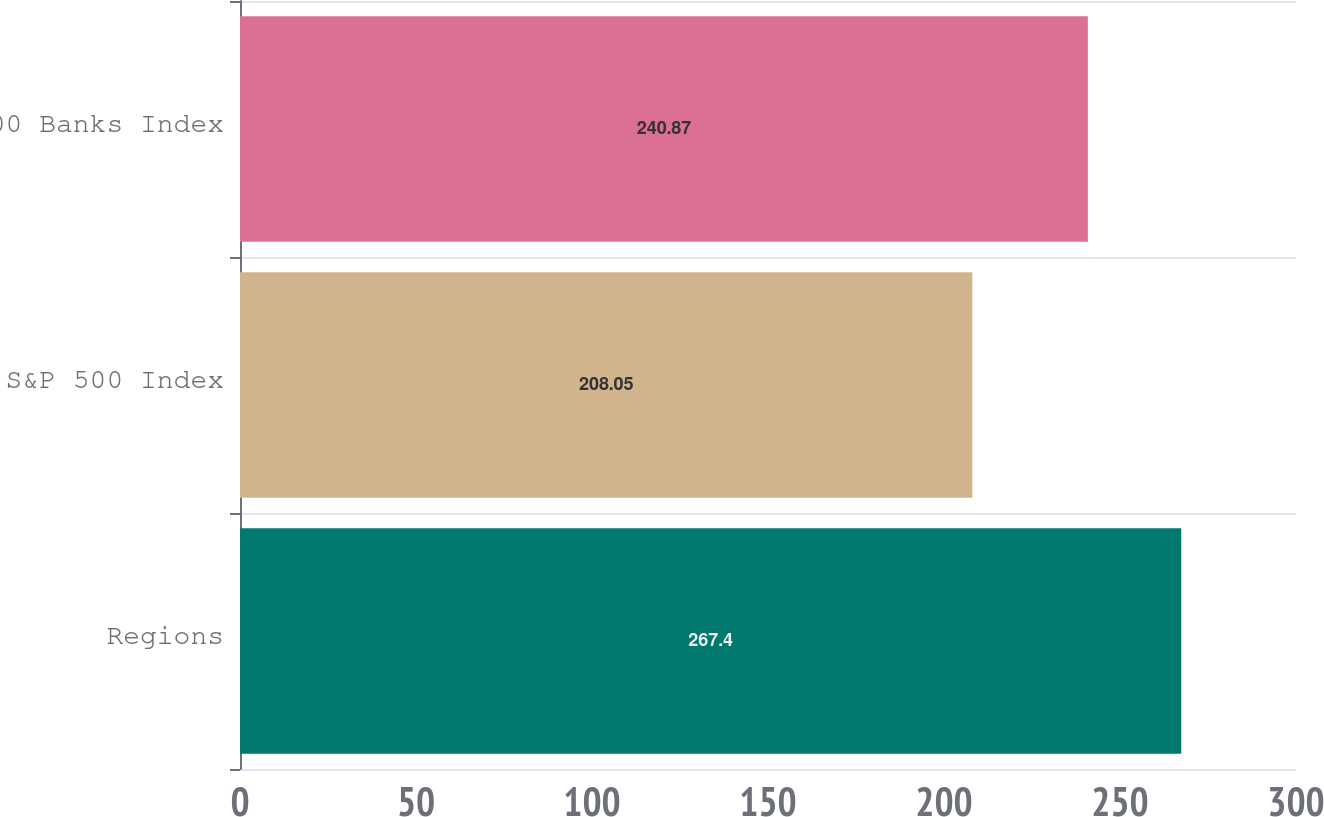Convert chart. <chart><loc_0><loc_0><loc_500><loc_500><bar_chart><fcel>Regions<fcel>S&P 500 Index<fcel>S&P 500 Banks Index<nl><fcel>267.4<fcel>208.05<fcel>240.87<nl></chart> 